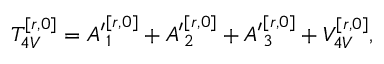<formula> <loc_0><loc_0><loc_500><loc_500>T _ { 4 V } ^ { [ r , 0 ] } = { A ^ { \prime } } _ { 1 } ^ { [ r , 0 ] } + { A ^ { \prime } } _ { 2 } ^ { [ r , 0 ] } + { A ^ { \prime } } _ { 3 } ^ { [ r , 0 ] } + V _ { 4 V } ^ { [ r , 0 ] } ,</formula> 